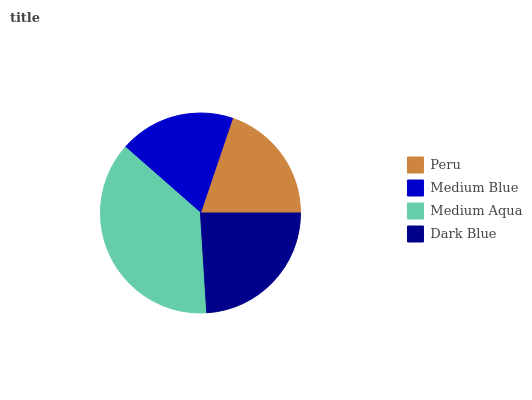Is Medium Blue the minimum?
Answer yes or no. Yes. Is Medium Aqua the maximum?
Answer yes or no. Yes. Is Medium Aqua the minimum?
Answer yes or no. No. Is Medium Blue the maximum?
Answer yes or no. No. Is Medium Aqua greater than Medium Blue?
Answer yes or no. Yes. Is Medium Blue less than Medium Aqua?
Answer yes or no. Yes. Is Medium Blue greater than Medium Aqua?
Answer yes or no. No. Is Medium Aqua less than Medium Blue?
Answer yes or no. No. Is Dark Blue the high median?
Answer yes or no. Yes. Is Peru the low median?
Answer yes or no. Yes. Is Peru the high median?
Answer yes or no. No. Is Medium Aqua the low median?
Answer yes or no. No. 